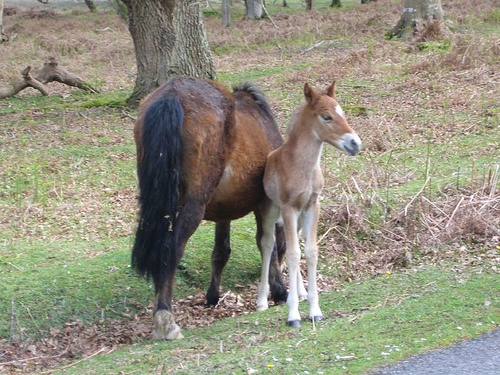Describe the objects in this image and their specific colors. I can see horse in darkgray, black, and gray tones and horse in darkgray, gray, and lightgray tones in this image. 